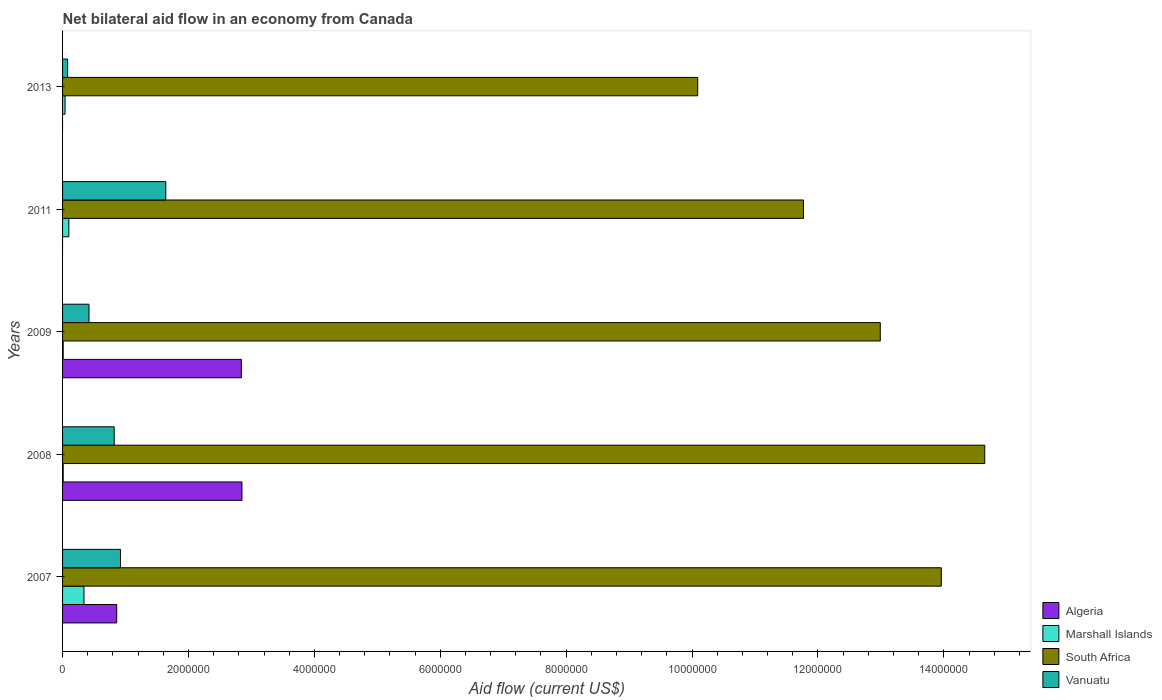How many different coloured bars are there?
Offer a terse response. 4. How many groups of bars are there?
Offer a very short reply. 5. Are the number of bars per tick equal to the number of legend labels?
Your answer should be compact. No. How many bars are there on the 5th tick from the top?
Ensure brevity in your answer.  4. In how many cases, is the number of bars for a given year not equal to the number of legend labels?
Your answer should be very brief. 2. What is the net bilateral aid flow in Algeria in 2011?
Your answer should be compact. 0. Across all years, what is the maximum net bilateral aid flow in Marshall Islands?
Offer a very short reply. 3.40e+05. Across all years, what is the minimum net bilateral aid flow in Algeria?
Provide a short and direct response. 0. What is the total net bilateral aid flow in South Africa in the graph?
Provide a succinct answer. 6.35e+07. What is the difference between the net bilateral aid flow in South Africa in 2009 and the net bilateral aid flow in Vanuatu in 2007?
Offer a very short reply. 1.21e+07. In the year 2009, what is the difference between the net bilateral aid flow in Algeria and net bilateral aid flow in Vanuatu?
Offer a very short reply. 2.42e+06. In how many years, is the net bilateral aid flow in Algeria greater than 14800000 US$?
Your answer should be compact. 0. What is the ratio of the net bilateral aid flow in Algeria in 2007 to that in 2009?
Ensure brevity in your answer.  0.3. Is the net bilateral aid flow in South Africa in 2007 less than that in 2013?
Ensure brevity in your answer.  No. Is the difference between the net bilateral aid flow in Algeria in 2008 and 2009 greater than the difference between the net bilateral aid flow in Vanuatu in 2008 and 2009?
Offer a very short reply. No. What is the difference between the highest and the second highest net bilateral aid flow in Marshall Islands?
Offer a very short reply. 2.40e+05. What is the difference between the highest and the lowest net bilateral aid flow in Vanuatu?
Your answer should be very brief. 1.56e+06. In how many years, is the net bilateral aid flow in Vanuatu greater than the average net bilateral aid flow in Vanuatu taken over all years?
Offer a very short reply. 3. Is the sum of the net bilateral aid flow in Marshall Islands in 2008 and 2011 greater than the maximum net bilateral aid flow in Algeria across all years?
Provide a succinct answer. No. Are all the bars in the graph horizontal?
Provide a short and direct response. Yes. How many years are there in the graph?
Offer a very short reply. 5. Does the graph contain any zero values?
Ensure brevity in your answer.  Yes. How many legend labels are there?
Give a very brief answer. 4. What is the title of the graph?
Make the answer very short. Net bilateral aid flow in an economy from Canada. What is the label or title of the X-axis?
Ensure brevity in your answer.  Aid flow (current US$). What is the label or title of the Y-axis?
Your response must be concise. Years. What is the Aid flow (current US$) of Algeria in 2007?
Provide a short and direct response. 8.60e+05. What is the Aid flow (current US$) of South Africa in 2007?
Your response must be concise. 1.40e+07. What is the Aid flow (current US$) of Vanuatu in 2007?
Provide a short and direct response. 9.20e+05. What is the Aid flow (current US$) in Algeria in 2008?
Give a very brief answer. 2.85e+06. What is the Aid flow (current US$) in South Africa in 2008?
Ensure brevity in your answer.  1.46e+07. What is the Aid flow (current US$) in Vanuatu in 2008?
Provide a short and direct response. 8.20e+05. What is the Aid flow (current US$) of Algeria in 2009?
Ensure brevity in your answer.  2.84e+06. What is the Aid flow (current US$) in South Africa in 2009?
Your response must be concise. 1.30e+07. What is the Aid flow (current US$) of Algeria in 2011?
Give a very brief answer. 0. What is the Aid flow (current US$) of Marshall Islands in 2011?
Ensure brevity in your answer.  1.00e+05. What is the Aid flow (current US$) in South Africa in 2011?
Give a very brief answer. 1.18e+07. What is the Aid flow (current US$) of Vanuatu in 2011?
Offer a very short reply. 1.64e+06. What is the Aid flow (current US$) in Algeria in 2013?
Provide a short and direct response. 0. What is the Aid flow (current US$) in South Africa in 2013?
Your answer should be very brief. 1.01e+07. Across all years, what is the maximum Aid flow (current US$) of Algeria?
Give a very brief answer. 2.85e+06. Across all years, what is the maximum Aid flow (current US$) of Marshall Islands?
Give a very brief answer. 3.40e+05. Across all years, what is the maximum Aid flow (current US$) in South Africa?
Ensure brevity in your answer.  1.46e+07. Across all years, what is the maximum Aid flow (current US$) of Vanuatu?
Keep it short and to the point. 1.64e+06. Across all years, what is the minimum Aid flow (current US$) of South Africa?
Give a very brief answer. 1.01e+07. Across all years, what is the minimum Aid flow (current US$) in Vanuatu?
Keep it short and to the point. 8.00e+04. What is the total Aid flow (current US$) in Algeria in the graph?
Your answer should be compact. 6.55e+06. What is the total Aid flow (current US$) in South Africa in the graph?
Your answer should be very brief. 6.35e+07. What is the total Aid flow (current US$) of Vanuatu in the graph?
Your response must be concise. 3.88e+06. What is the difference between the Aid flow (current US$) in Algeria in 2007 and that in 2008?
Offer a terse response. -1.99e+06. What is the difference between the Aid flow (current US$) of Marshall Islands in 2007 and that in 2008?
Your response must be concise. 3.30e+05. What is the difference between the Aid flow (current US$) of South Africa in 2007 and that in 2008?
Keep it short and to the point. -6.90e+05. What is the difference between the Aid flow (current US$) of Algeria in 2007 and that in 2009?
Your answer should be compact. -1.98e+06. What is the difference between the Aid flow (current US$) of Marshall Islands in 2007 and that in 2009?
Provide a short and direct response. 3.30e+05. What is the difference between the Aid flow (current US$) of South Africa in 2007 and that in 2009?
Make the answer very short. 9.70e+05. What is the difference between the Aid flow (current US$) in Vanuatu in 2007 and that in 2009?
Your response must be concise. 5.00e+05. What is the difference between the Aid flow (current US$) of Marshall Islands in 2007 and that in 2011?
Offer a very short reply. 2.40e+05. What is the difference between the Aid flow (current US$) of South Africa in 2007 and that in 2011?
Offer a very short reply. 2.19e+06. What is the difference between the Aid flow (current US$) in Vanuatu in 2007 and that in 2011?
Give a very brief answer. -7.20e+05. What is the difference between the Aid flow (current US$) of Marshall Islands in 2007 and that in 2013?
Give a very brief answer. 3.00e+05. What is the difference between the Aid flow (current US$) in South Africa in 2007 and that in 2013?
Keep it short and to the point. 3.87e+06. What is the difference between the Aid flow (current US$) of Vanuatu in 2007 and that in 2013?
Provide a short and direct response. 8.40e+05. What is the difference between the Aid flow (current US$) of South Africa in 2008 and that in 2009?
Your answer should be compact. 1.66e+06. What is the difference between the Aid flow (current US$) of Vanuatu in 2008 and that in 2009?
Provide a succinct answer. 4.00e+05. What is the difference between the Aid flow (current US$) of South Africa in 2008 and that in 2011?
Keep it short and to the point. 2.88e+06. What is the difference between the Aid flow (current US$) in Vanuatu in 2008 and that in 2011?
Provide a short and direct response. -8.20e+05. What is the difference between the Aid flow (current US$) of Marshall Islands in 2008 and that in 2013?
Give a very brief answer. -3.00e+04. What is the difference between the Aid flow (current US$) of South Africa in 2008 and that in 2013?
Ensure brevity in your answer.  4.56e+06. What is the difference between the Aid flow (current US$) in Vanuatu in 2008 and that in 2013?
Offer a very short reply. 7.40e+05. What is the difference between the Aid flow (current US$) in Marshall Islands in 2009 and that in 2011?
Your answer should be very brief. -9.00e+04. What is the difference between the Aid flow (current US$) of South Africa in 2009 and that in 2011?
Make the answer very short. 1.22e+06. What is the difference between the Aid flow (current US$) in Vanuatu in 2009 and that in 2011?
Offer a very short reply. -1.22e+06. What is the difference between the Aid flow (current US$) in Marshall Islands in 2009 and that in 2013?
Make the answer very short. -3.00e+04. What is the difference between the Aid flow (current US$) in South Africa in 2009 and that in 2013?
Give a very brief answer. 2.90e+06. What is the difference between the Aid flow (current US$) in South Africa in 2011 and that in 2013?
Ensure brevity in your answer.  1.68e+06. What is the difference between the Aid flow (current US$) in Vanuatu in 2011 and that in 2013?
Your response must be concise. 1.56e+06. What is the difference between the Aid flow (current US$) of Algeria in 2007 and the Aid flow (current US$) of Marshall Islands in 2008?
Your response must be concise. 8.50e+05. What is the difference between the Aid flow (current US$) in Algeria in 2007 and the Aid flow (current US$) in South Africa in 2008?
Keep it short and to the point. -1.38e+07. What is the difference between the Aid flow (current US$) in Marshall Islands in 2007 and the Aid flow (current US$) in South Africa in 2008?
Offer a terse response. -1.43e+07. What is the difference between the Aid flow (current US$) of Marshall Islands in 2007 and the Aid flow (current US$) of Vanuatu in 2008?
Offer a very short reply. -4.80e+05. What is the difference between the Aid flow (current US$) of South Africa in 2007 and the Aid flow (current US$) of Vanuatu in 2008?
Offer a very short reply. 1.31e+07. What is the difference between the Aid flow (current US$) of Algeria in 2007 and the Aid flow (current US$) of Marshall Islands in 2009?
Ensure brevity in your answer.  8.50e+05. What is the difference between the Aid flow (current US$) of Algeria in 2007 and the Aid flow (current US$) of South Africa in 2009?
Give a very brief answer. -1.21e+07. What is the difference between the Aid flow (current US$) of Algeria in 2007 and the Aid flow (current US$) of Vanuatu in 2009?
Make the answer very short. 4.40e+05. What is the difference between the Aid flow (current US$) of Marshall Islands in 2007 and the Aid flow (current US$) of South Africa in 2009?
Give a very brief answer. -1.26e+07. What is the difference between the Aid flow (current US$) in South Africa in 2007 and the Aid flow (current US$) in Vanuatu in 2009?
Give a very brief answer. 1.35e+07. What is the difference between the Aid flow (current US$) of Algeria in 2007 and the Aid flow (current US$) of Marshall Islands in 2011?
Provide a succinct answer. 7.60e+05. What is the difference between the Aid flow (current US$) in Algeria in 2007 and the Aid flow (current US$) in South Africa in 2011?
Offer a very short reply. -1.09e+07. What is the difference between the Aid flow (current US$) of Algeria in 2007 and the Aid flow (current US$) of Vanuatu in 2011?
Your response must be concise. -7.80e+05. What is the difference between the Aid flow (current US$) in Marshall Islands in 2007 and the Aid flow (current US$) in South Africa in 2011?
Offer a terse response. -1.14e+07. What is the difference between the Aid flow (current US$) of Marshall Islands in 2007 and the Aid flow (current US$) of Vanuatu in 2011?
Keep it short and to the point. -1.30e+06. What is the difference between the Aid flow (current US$) in South Africa in 2007 and the Aid flow (current US$) in Vanuatu in 2011?
Provide a short and direct response. 1.23e+07. What is the difference between the Aid flow (current US$) in Algeria in 2007 and the Aid flow (current US$) in Marshall Islands in 2013?
Your response must be concise. 8.20e+05. What is the difference between the Aid flow (current US$) in Algeria in 2007 and the Aid flow (current US$) in South Africa in 2013?
Provide a short and direct response. -9.23e+06. What is the difference between the Aid flow (current US$) of Algeria in 2007 and the Aid flow (current US$) of Vanuatu in 2013?
Provide a succinct answer. 7.80e+05. What is the difference between the Aid flow (current US$) in Marshall Islands in 2007 and the Aid flow (current US$) in South Africa in 2013?
Your response must be concise. -9.75e+06. What is the difference between the Aid flow (current US$) of South Africa in 2007 and the Aid flow (current US$) of Vanuatu in 2013?
Provide a short and direct response. 1.39e+07. What is the difference between the Aid flow (current US$) of Algeria in 2008 and the Aid flow (current US$) of Marshall Islands in 2009?
Provide a short and direct response. 2.84e+06. What is the difference between the Aid flow (current US$) of Algeria in 2008 and the Aid flow (current US$) of South Africa in 2009?
Give a very brief answer. -1.01e+07. What is the difference between the Aid flow (current US$) in Algeria in 2008 and the Aid flow (current US$) in Vanuatu in 2009?
Your answer should be compact. 2.43e+06. What is the difference between the Aid flow (current US$) of Marshall Islands in 2008 and the Aid flow (current US$) of South Africa in 2009?
Your response must be concise. -1.30e+07. What is the difference between the Aid flow (current US$) of Marshall Islands in 2008 and the Aid flow (current US$) of Vanuatu in 2009?
Offer a very short reply. -4.10e+05. What is the difference between the Aid flow (current US$) of South Africa in 2008 and the Aid flow (current US$) of Vanuatu in 2009?
Your response must be concise. 1.42e+07. What is the difference between the Aid flow (current US$) in Algeria in 2008 and the Aid flow (current US$) in Marshall Islands in 2011?
Ensure brevity in your answer.  2.75e+06. What is the difference between the Aid flow (current US$) of Algeria in 2008 and the Aid flow (current US$) of South Africa in 2011?
Provide a short and direct response. -8.92e+06. What is the difference between the Aid flow (current US$) in Algeria in 2008 and the Aid flow (current US$) in Vanuatu in 2011?
Ensure brevity in your answer.  1.21e+06. What is the difference between the Aid flow (current US$) of Marshall Islands in 2008 and the Aid flow (current US$) of South Africa in 2011?
Keep it short and to the point. -1.18e+07. What is the difference between the Aid flow (current US$) of Marshall Islands in 2008 and the Aid flow (current US$) of Vanuatu in 2011?
Offer a very short reply. -1.63e+06. What is the difference between the Aid flow (current US$) in South Africa in 2008 and the Aid flow (current US$) in Vanuatu in 2011?
Offer a very short reply. 1.30e+07. What is the difference between the Aid flow (current US$) in Algeria in 2008 and the Aid flow (current US$) in Marshall Islands in 2013?
Provide a short and direct response. 2.81e+06. What is the difference between the Aid flow (current US$) of Algeria in 2008 and the Aid flow (current US$) of South Africa in 2013?
Your answer should be very brief. -7.24e+06. What is the difference between the Aid flow (current US$) of Algeria in 2008 and the Aid flow (current US$) of Vanuatu in 2013?
Make the answer very short. 2.77e+06. What is the difference between the Aid flow (current US$) in Marshall Islands in 2008 and the Aid flow (current US$) in South Africa in 2013?
Offer a very short reply. -1.01e+07. What is the difference between the Aid flow (current US$) in Marshall Islands in 2008 and the Aid flow (current US$) in Vanuatu in 2013?
Offer a very short reply. -7.00e+04. What is the difference between the Aid flow (current US$) of South Africa in 2008 and the Aid flow (current US$) of Vanuatu in 2013?
Offer a terse response. 1.46e+07. What is the difference between the Aid flow (current US$) in Algeria in 2009 and the Aid flow (current US$) in Marshall Islands in 2011?
Give a very brief answer. 2.74e+06. What is the difference between the Aid flow (current US$) of Algeria in 2009 and the Aid flow (current US$) of South Africa in 2011?
Your response must be concise. -8.93e+06. What is the difference between the Aid flow (current US$) in Algeria in 2009 and the Aid flow (current US$) in Vanuatu in 2011?
Keep it short and to the point. 1.20e+06. What is the difference between the Aid flow (current US$) in Marshall Islands in 2009 and the Aid flow (current US$) in South Africa in 2011?
Provide a succinct answer. -1.18e+07. What is the difference between the Aid flow (current US$) in Marshall Islands in 2009 and the Aid flow (current US$) in Vanuatu in 2011?
Give a very brief answer. -1.63e+06. What is the difference between the Aid flow (current US$) of South Africa in 2009 and the Aid flow (current US$) of Vanuatu in 2011?
Offer a terse response. 1.14e+07. What is the difference between the Aid flow (current US$) in Algeria in 2009 and the Aid flow (current US$) in Marshall Islands in 2013?
Provide a succinct answer. 2.80e+06. What is the difference between the Aid flow (current US$) in Algeria in 2009 and the Aid flow (current US$) in South Africa in 2013?
Offer a terse response. -7.25e+06. What is the difference between the Aid flow (current US$) of Algeria in 2009 and the Aid flow (current US$) of Vanuatu in 2013?
Make the answer very short. 2.76e+06. What is the difference between the Aid flow (current US$) in Marshall Islands in 2009 and the Aid flow (current US$) in South Africa in 2013?
Provide a succinct answer. -1.01e+07. What is the difference between the Aid flow (current US$) in Marshall Islands in 2009 and the Aid flow (current US$) in Vanuatu in 2013?
Your response must be concise. -7.00e+04. What is the difference between the Aid flow (current US$) of South Africa in 2009 and the Aid flow (current US$) of Vanuatu in 2013?
Your answer should be compact. 1.29e+07. What is the difference between the Aid flow (current US$) in Marshall Islands in 2011 and the Aid flow (current US$) in South Africa in 2013?
Give a very brief answer. -9.99e+06. What is the difference between the Aid flow (current US$) in Marshall Islands in 2011 and the Aid flow (current US$) in Vanuatu in 2013?
Your answer should be compact. 2.00e+04. What is the difference between the Aid flow (current US$) in South Africa in 2011 and the Aid flow (current US$) in Vanuatu in 2013?
Make the answer very short. 1.17e+07. What is the average Aid flow (current US$) of Algeria per year?
Your answer should be compact. 1.31e+06. What is the average Aid flow (current US$) in South Africa per year?
Your answer should be compact. 1.27e+07. What is the average Aid flow (current US$) in Vanuatu per year?
Make the answer very short. 7.76e+05. In the year 2007, what is the difference between the Aid flow (current US$) of Algeria and Aid flow (current US$) of Marshall Islands?
Offer a very short reply. 5.20e+05. In the year 2007, what is the difference between the Aid flow (current US$) of Algeria and Aid flow (current US$) of South Africa?
Keep it short and to the point. -1.31e+07. In the year 2007, what is the difference between the Aid flow (current US$) in Algeria and Aid flow (current US$) in Vanuatu?
Your answer should be very brief. -6.00e+04. In the year 2007, what is the difference between the Aid flow (current US$) of Marshall Islands and Aid flow (current US$) of South Africa?
Give a very brief answer. -1.36e+07. In the year 2007, what is the difference between the Aid flow (current US$) in Marshall Islands and Aid flow (current US$) in Vanuatu?
Provide a succinct answer. -5.80e+05. In the year 2007, what is the difference between the Aid flow (current US$) of South Africa and Aid flow (current US$) of Vanuatu?
Provide a succinct answer. 1.30e+07. In the year 2008, what is the difference between the Aid flow (current US$) of Algeria and Aid flow (current US$) of Marshall Islands?
Offer a very short reply. 2.84e+06. In the year 2008, what is the difference between the Aid flow (current US$) in Algeria and Aid flow (current US$) in South Africa?
Give a very brief answer. -1.18e+07. In the year 2008, what is the difference between the Aid flow (current US$) in Algeria and Aid flow (current US$) in Vanuatu?
Offer a very short reply. 2.03e+06. In the year 2008, what is the difference between the Aid flow (current US$) in Marshall Islands and Aid flow (current US$) in South Africa?
Your answer should be compact. -1.46e+07. In the year 2008, what is the difference between the Aid flow (current US$) of Marshall Islands and Aid flow (current US$) of Vanuatu?
Offer a terse response. -8.10e+05. In the year 2008, what is the difference between the Aid flow (current US$) of South Africa and Aid flow (current US$) of Vanuatu?
Offer a very short reply. 1.38e+07. In the year 2009, what is the difference between the Aid flow (current US$) of Algeria and Aid flow (current US$) of Marshall Islands?
Provide a succinct answer. 2.83e+06. In the year 2009, what is the difference between the Aid flow (current US$) of Algeria and Aid flow (current US$) of South Africa?
Provide a short and direct response. -1.02e+07. In the year 2009, what is the difference between the Aid flow (current US$) of Algeria and Aid flow (current US$) of Vanuatu?
Your answer should be compact. 2.42e+06. In the year 2009, what is the difference between the Aid flow (current US$) of Marshall Islands and Aid flow (current US$) of South Africa?
Offer a terse response. -1.30e+07. In the year 2009, what is the difference between the Aid flow (current US$) of Marshall Islands and Aid flow (current US$) of Vanuatu?
Ensure brevity in your answer.  -4.10e+05. In the year 2009, what is the difference between the Aid flow (current US$) of South Africa and Aid flow (current US$) of Vanuatu?
Ensure brevity in your answer.  1.26e+07. In the year 2011, what is the difference between the Aid flow (current US$) in Marshall Islands and Aid flow (current US$) in South Africa?
Your response must be concise. -1.17e+07. In the year 2011, what is the difference between the Aid flow (current US$) in Marshall Islands and Aid flow (current US$) in Vanuatu?
Offer a terse response. -1.54e+06. In the year 2011, what is the difference between the Aid flow (current US$) in South Africa and Aid flow (current US$) in Vanuatu?
Your answer should be compact. 1.01e+07. In the year 2013, what is the difference between the Aid flow (current US$) of Marshall Islands and Aid flow (current US$) of South Africa?
Offer a terse response. -1.00e+07. In the year 2013, what is the difference between the Aid flow (current US$) of South Africa and Aid flow (current US$) of Vanuatu?
Offer a very short reply. 1.00e+07. What is the ratio of the Aid flow (current US$) of Algeria in 2007 to that in 2008?
Your answer should be very brief. 0.3. What is the ratio of the Aid flow (current US$) of Marshall Islands in 2007 to that in 2008?
Ensure brevity in your answer.  34. What is the ratio of the Aid flow (current US$) in South Africa in 2007 to that in 2008?
Provide a succinct answer. 0.95. What is the ratio of the Aid flow (current US$) of Vanuatu in 2007 to that in 2008?
Your response must be concise. 1.12. What is the ratio of the Aid flow (current US$) of Algeria in 2007 to that in 2009?
Your answer should be compact. 0.3. What is the ratio of the Aid flow (current US$) of South Africa in 2007 to that in 2009?
Provide a succinct answer. 1.07. What is the ratio of the Aid flow (current US$) of Vanuatu in 2007 to that in 2009?
Offer a terse response. 2.19. What is the ratio of the Aid flow (current US$) in South Africa in 2007 to that in 2011?
Offer a terse response. 1.19. What is the ratio of the Aid flow (current US$) in Vanuatu in 2007 to that in 2011?
Ensure brevity in your answer.  0.56. What is the ratio of the Aid flow (current US$) of South Africa in 2007 to that in 2013?
Provide a succinct answer. 1.38. What is the ratio of the Aid flow (current US$) of South Africa in 2008 to that in 2009?
Provide a short and direct response. 1.13. What is the ratio of the Aid flow (current US$) in Vanuatu in 2008 to that in 2009?
Your answer should be compact. 1.95. What is the ratio of the Aid flow (current US$) of South Africa in 2008 to that in 2011?
Give a very brief answer. 1.24. What is the ratio of the Aid flow (current US$) in Marshall Islands in 2008 to that in 2013?
Provide a short and direct response. 0.25. What is the ratio of the Aid flow (current US$) in South Africa in 2008 to that in 2013?
Provide a short and direct response. 1.45. What is the ratio of the Aid flow (current US$) in Vanuatu in 2008 to that in 2013?
Keep it short and to the point. 10.25. What is the ratio of the Aid flow (current US$) in Marshall Islands in 2009 to that in 2011?
Provide a short and direct response. 0.1. What is the ratio of the Aid flow (current US$) of South Africa in 2009 to that in 2011?
Your answer should be compact. 1.1. What is the ratio of the Aid flow (current US$) in Vanuatu in 2009 to that in 2011?
Provide a succinct answer. 0.26. What is the ratio of the Aid flow (current US$) in Marshall Islands in 2009 to that in 2013?
Your answer should be very brief. 0.25. What is the ratio of the Aid flow (current US$) of South Africa in 2009 to that in 2013?
Offer a very short reply. 1.29. What is the ratio of the Aid flow (current US$) in Vanuatu in 2009 to that in 2013?
Offer a terse response. 5.25. What is the ratio of the Aid flow (current US$) in Marshall Islands in 2011 to that in 2013?
Offer a terse response. 2.5. What is the ratio of the Aid flow (current US$) in South Africa in 2011 to that in 2013?
Give a very brief answer. 1.17. What is the difference between the highest and the second highest Aid flow (current US$) of Marshall Islands?
Your answer should be very brief. 2.40e+05. What is the difference between the highest and the second highest Aid flow (current US$) in South Africa?
Offer a terse response. 6.90e+05. What is the difference between the highest and the second highest Aid flow (current US$) of Vanuatu?
Make the answer very short. 7.20e+05. What is the difference between the highest and the lowest Aid flow (current US$) of Algeria?
Ensure brevity in your answer.  2.85e+06. What is the difference between the highest and the lowest Aid flow (current US$) in Marshall Islands?
Offer a very short reply. 3.30e+05. What is the difference between the highest and the lowest Aid flow (current US$) of South Africa?
Give a very brief answer. 4.56e+06. What is the difference between the highest and the lowest Aid flow (current US$) in Vanuatu?
Give a very brief answer. 1.56e+06. 